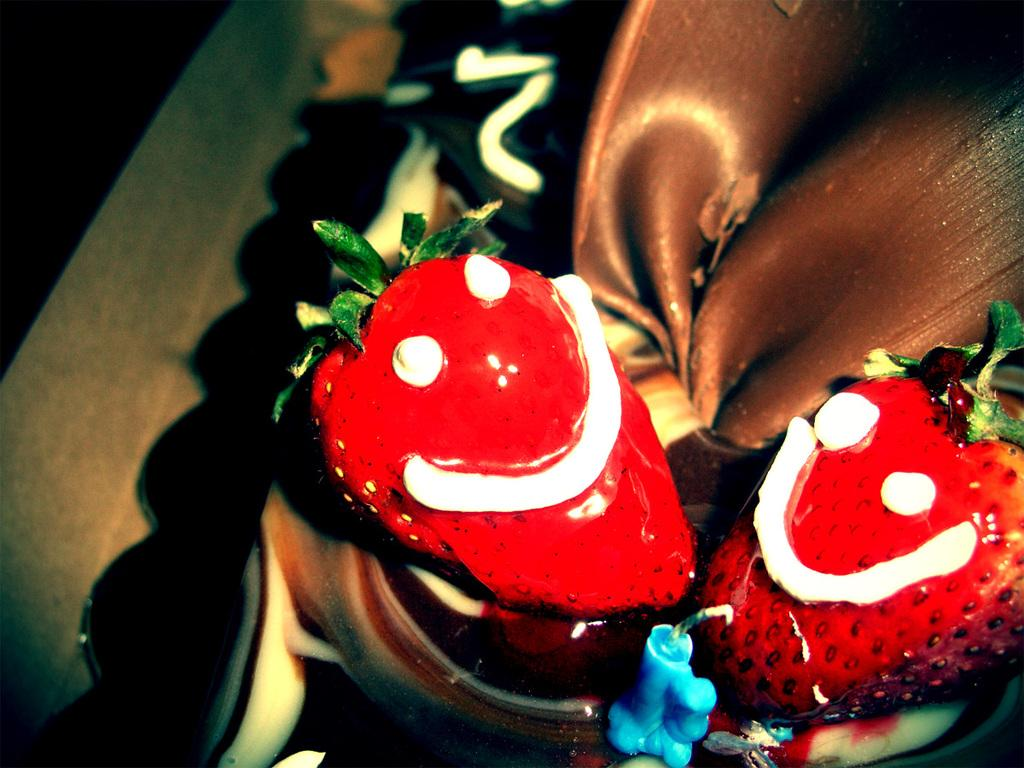What is the main food item in the image? There is a piece of cake in the image. What is placed on top of the cake? There is a candle on the cake. What type of fruit is on top of the cake? Strawberries are present on top of the cake. What type of scent can be smelled coming from the cake in the image? There is no indication of scent in the image, so it cannot be determined. 